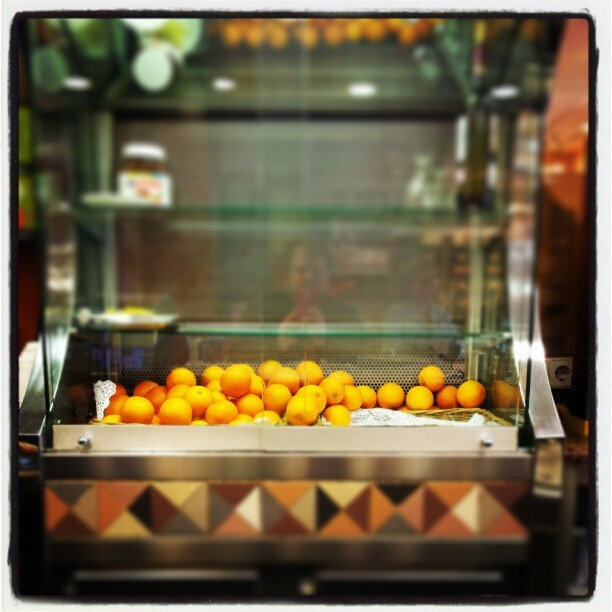Describe the objects in this image and their specific colors. I can see orange in ivory, gold, orange, red, and brown tones, people in ivory, gray, and olive tones, people in ivory and gray tones, and orange in ivory, maroon, red, brown, and black tones in this image. 